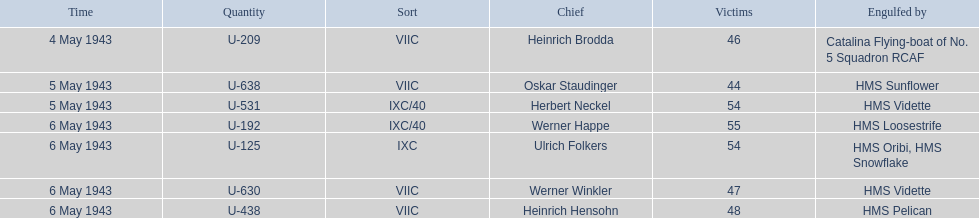Aside from oskar staudinger what was the name of the other captain of the u-boat loast on may 5? Herbert Neckel. 